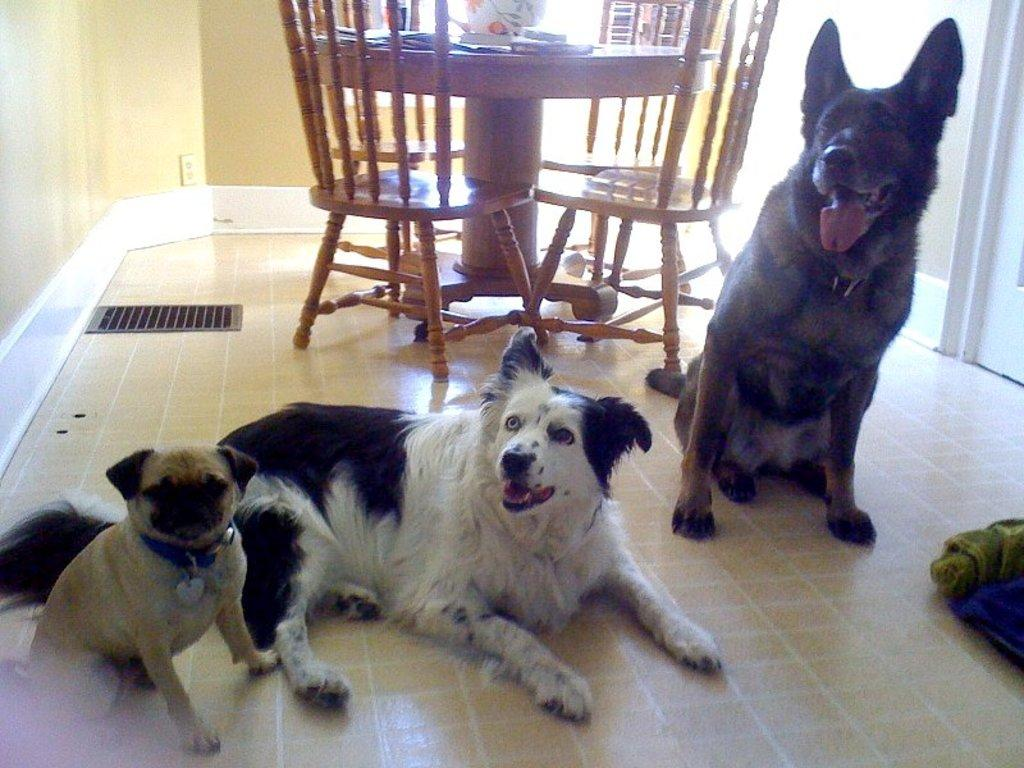How many dogs are present in the image? There are three dogs in the image. Where are the dogs located in relation to the dining table? The dogs are sitting beside the dining table. What type of wound can be seen on the afterthought in the image? There is no afterthought or wound present in the image; it features three dogs sitting beside a dining table. 